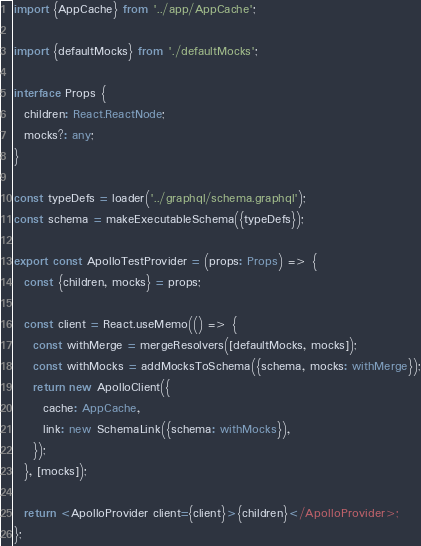<code> <loc_0><loc_0><loc_500><loc_500><_TypeScript_>import {AppCache} from '../app/AppCache';

import {defaultMocks} from './defaultMocks';

interface Props {
  children: React.ReactNode;
  mocks?: any;
}

const typeDefs = loader('../graphql/schema.graphql');
const schema = makeExecutableSchema({typeDefs});

export const ApolloTestProvider = (props: Props) => {
  const {children, mocks} = props;

  const client = React.useMemo(() => {
    const withMerge = mergeResolvers([defaultMocks, mocks]);
    const withMocks = addMocksToSchema({schema, mocks: withMerge});
    return new ApolloClient({
      cache: AppCache,
      link: new SchemaLink({schema: withMocks}),
    });
  }, [mocks]);

  return <ApolloProvider client={client}>{children}</ApolloProvider>;
};
</code> 